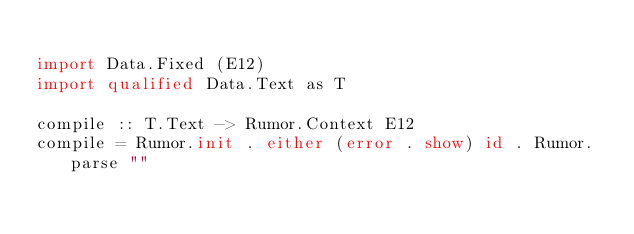Convert code to text. <code><loc_0><loc_0><loc_500><loc_500><_Haskell_>
import Data.Fixed (E12)
import qualified Data.Text as T

compile :: T.Text -> Rumor.Context E12
compile = Rumor.init . either (error . show) id . Rumor.parse ""
</code> 